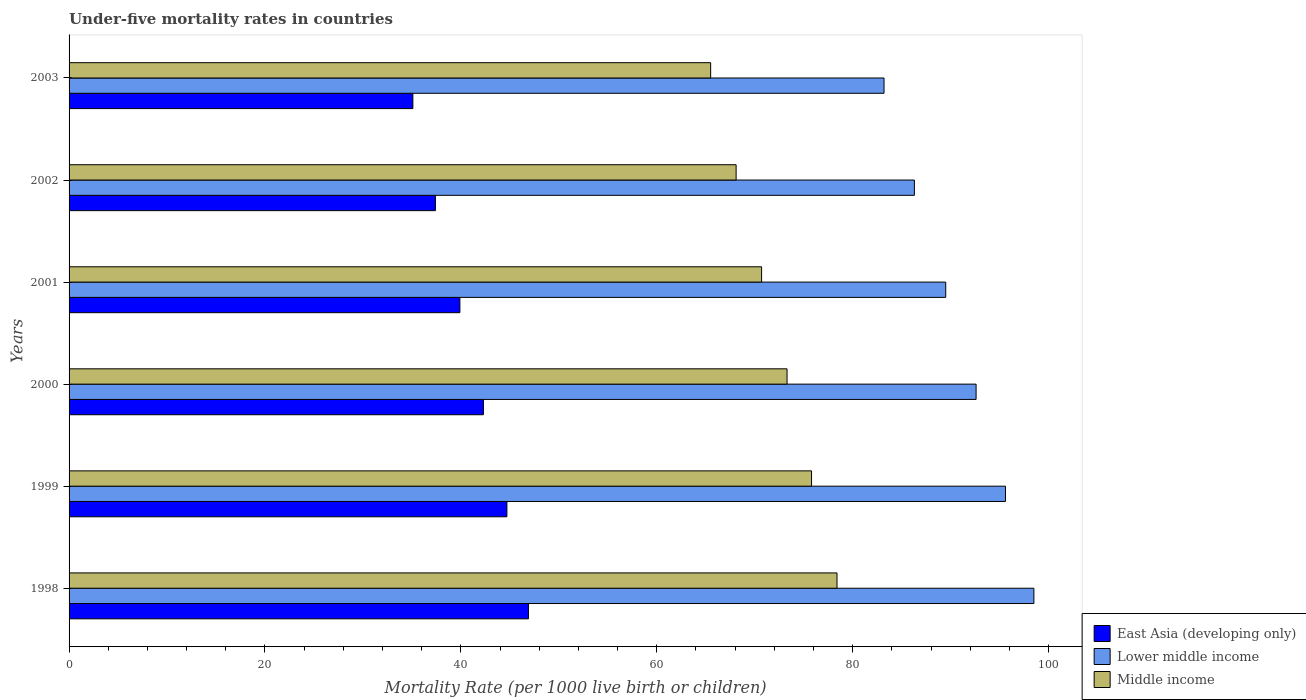How many bars are there on the 2nd tick from the top?
Your response must be concise. 3. How many bars are there on the 6th tick from the bottom?
Offer a very short reply. 3. What is the label of the 4th group of bars from the top?
Offer a very short reply. 2000. In how many cases, is the number of bars for a given year not equal to the number of legend labels?
Give a very brief answer. 0. What is the under-five mortality rate in Middle income in 2000?
Keep it short and to the point. 73.3. Across all years, what is the maximum under-five mortality rate in Lower middle income?
Your answer should be compact. 98.5. Across all years, what is the minimum under-five mortality rate in Middle income?
Provide a succinct answer. 65.5. In which year was the under-five mortality rate in East Asia (developing only) maximum?
Your answer should be compact. 1998. What is the total under-five mortality rate in Middle income in the graph?
Give a very brief answer. 431.8. What is the difference between the under-five mortality rate in Middle income in 1999 and that in 2003?
Offer a very short reply. 10.3. What is the difference between the under-five mortality rate in East Asia (developing only) in 2001 and the under-five mortality rate in Lower middle income in 1999?
Your answer should be compact. -55.7. What is the average under-five mortality rate in Middle income per year?
Give a very brief answer. 71.97. In the year 2002, what is the difference between the under-five mortality rate in Lower middle income and under-five mortality rate in Middle income?
Your answer should be compact. 18.2. In how many years, is the under-five mortality rate in East Asia (developing only) greater than 12 ?
Your response must be concise. 6. What is the ratio of the under-five mortality rate in East Asia (developing only) in 1999 to that in 2001?
Your answer should be very brief. 1.12. Is the difference between the under-five mortality rate in Lower middle income in 2001 and 2003 greater than the difference between the under-five mortality rate in Middle income in 2001 and 2003?
Offer a terse response. Yes. What is the difference between the highest and the second highest under-five mortality rate in Lower middle income?
Your response must be concise. 2.9. What is the difference between the highest and the lowest under-five mortality rate in Middle income?
Your answer should be very brief. 12.9. What does the 3rd bar from the top in 2002 represents?
Offer a terse response. East Asia (developing only). What does the 1st bar from the bottom in 1999 represents?
Offer a terse response. East Asia (developing only). What is the difference between two consecutive major ticks on the X-axis?
Your answer should be very brief. 20. Does the graph contain grids?
Provide a succinct answer. No. Where does the legend appear in the graph?
Keep it short and to the point. Bottom right. What is the title of the graph?
Your answer should be very brief. Under-five mortality rates in countries. What is the label or title of the X-axis?
Your response must be concise. Mortality Rate (per 1000 live birth or children). What is the label or title of the Y-axis?
Ensure brevity in your answer.  Years. What is the Mortality Rate (per 1000 live birth or children) in East Asia (developing only) in 1998?
Offer a very short reply. 46.9. What is the Mortality Rate (per 1000 live birth or children) of Lower middle income in 1998?
Your response must be concise. 98.5. What is the Mortality Rate (per 1000 live birth or children) in Middle income in 1998?
Provide a short and direct response. 78.4. What is the Mortality Rate (per 1000 live birth or children) in East Asia (developing only) in 1999?
Your response must be concise. 44.7. What is the Mortality Rate (per 1000 live birth or children) of Lower middle income in 1999?
Offer a very short reply. 95.6. What is the Mortality Rate (per 1000 live birth or children) of Middle income in 1999?
Your response must be concise. 75.8. What is the Mortality Rate (per 1000 live birth or children) of East Asia (developing only) in 2000?
Offer a very short reply. 42.3. What is the Mortality Rate (per 1000 live birth or children) in Lower middle income in 2000?
Your answer should be compact. 92.6. What is the Mortality Rate (per 1000 live birth or children) in Middle income in 2000?
Provide a short and direct response. 73.3. What is the Mortality Rate (per 1000 live birth or children) in East Asia (developing only) in 2001?
Provide a succinct answer. 39.9. What is the Mortality Rate (per 1000 live birth or children) of Lower middle income in 2001?
Provide a short and direct response. 89.5. What is the Mortality Rate (per 1000 live birth or children) of Middle income in 2001?
Your answer should be very brief. 70.7. What is the Mortality Rate (per 1000 live birth or children) in East Asia (developing only) in 2002?
Ensure brevity in your answer.  37.4. What is the Mortality Rate (per 1000 live birth or children) in Lower middle income in 2002?
Provide a succinct answer. 86.3. What is the Mortality Rate (per 1000 live birth or children) in Middle income in 2002?
Your response must be concise. 68.1. What is the Mortality Rate (per 1000 live birth or children) of East Asia (developing only) in 2003?
Provide a short and direct response. 35.1. What is the Mortality Rate (per 1000 live birth or children) of Lower middle income in 2003?
Your response must be concise. 83.2. What is the Mortality Rate (per 1000 live birth or children) in Middle income in 2003?
Your answer should be compact. 65.5. Across all years, what is the maximum Mortality Rate (per 1000 live birth or children) in East Asia (developing only)?
Provide a succinct answer. 46.9. Across all years, what is the maximum Mortality Rate (per 1000 live birth or children) in Lower middle income?
Ensure brevity in your answer.  98.5. Across all years, what is the maximum Mortality Rate (per 1000 live birth or children) in Middle income?
Ensure brevity in your answer.  78.4. Across all years, what is the minimum Mortality Rate (per 1000 live birth or children) in East Asia (developing only)?
Make the answer very short. 35.1. Across all years, what is the minimum Mortality Rate (per 1000 live birth or children) of Lower middle income?
Keep it short and to the point. 83.2. Across all years, what is the minimum Mortality Rate (per 1000 live birth or children) of Middle income?
Make the answer very short. 65.5. What is the total Mortality Rate (per 1000 live birth or children) of East Asia (developing only) in the graph?
Provide a short and direct response. 246.3. What is the total Mortality Rate (per 1000 live birth or children) of Lower middle income in the graph?
Give a very brief answer. 545.7. What is the total Mortality Rate (per 1000 live birth or children) in Middle income in the graph?
Your response must be concise. 431.8. What is the difference between the Mortality Rate (per 1000 live birth or children) in East Asia (developing only) in 1998 and that in 1999?
Make the answer very short. 2.2. What is the difference between the Mortality Rate (per 1000 live birth or children) of Lower middle income in 1998 and that in 1999?
Ensure brevity in your answer.  2.9. What is the difference between the Mortality Rate (per 1000 live birth or children) in Middle income in 1998 and that in 1999?
Offer a very short reply. 2.6. What is the difference between the Mortality Rate (per 1000 live birth or children) of Middle income in 1998 and that in 2000?
Your answer should be very brief. 5.1. What is the difference between the Mortality Rate (per 1000 live birth or children) in East Asia (developing only) in 1998 and that in 2001?
Ensure brevity in your answer.  7. What is the difference between the Mortality Rate (per 1000 live birth or children) of Lower middle income in 1998 and that in 2001?
Give a very brief answer. 9. What is the difference between the Mortality Rate (per 1000 live birth or children) of East Asia (developing only) in 1998 and that in 2002?
Give a very brief answer. 9.5. What is the difference between the Mortality Rate (per 1000 live birth or children) in Middle income in 1998 and that in 2002?
Your answer should be very brief. 10.3. What is the difference between the Mortality Rate (per 1000 live birth or children) in Lower middle income in 1998 and that in 2003?
Provide a short and direct response. 15.3. What is the difference between the Mortality Rate (per 1000 live birth or children) in East Asia (developing only) in 1999 and that in 2000?
Offer a very short reply. 2.4. What is the difference between the Mortality Rate (per 1000 live birth or children) in Middle income in 1999 and that in 2000?
Your response must be concise. 2.5. What is the difference between the Mortality Rate (per 1000 live birth or children) of East Asia (developing only) in 1999 and that in 2001?
Make the answer very short. 4.8. What is the difference between the Mortality Rate (per 1000 live birth or children) of Middle income in 1999 and that in 2001?
Provide a short and direct response. 5.1. What is the difference between the Mortality Rate (per 1000 live birth or children) of East Asia (developing only) in 1999 and that in 2002?
Provide a short and direct response. 7.3. What is the difference between the Mortality Rate (per 1000 live birth or children) in Lower middle income in 1999 and that in 2002?
Make the answer very short. 9.3. What is the difference between the Mortality Rate (per 1000 live birth or children) in East Asia (developing only) in 1999 and that in 2003?
Give a very brief answer. 9.6. What is the difference between the Mortality Rate (per 1000 live birth or children) of Lower middle income in 1999 and that in 2003?
Ensure brevity in your answer.  12.4. What is the difference between the Mortality Rate (per 1000 live birth or children) of East Asia (developing only) in 2000 and that in 2001?
Give a very brief answer. 2.4. What is the difference between the Mortality Rate (per 1000 live birth or children) of Middle income in 2000 and that in 2001?
Provide a short and direct response. 2.6. What is the difference between the Mortality Rate (per 1000 live birth or children) of Lower middle income in 2000 and that in 2002?
Offer a terse response. 6.3. What is the difference between the Mortality Rate (per 1000 live birth or children) in Middle income in 2000 and that in 2002?
Offer a very short reply. 5.2. What is the difference between the Mortality Rate (per 1000 live birth or children) of Middle income in 2000 and that in 2003?
Your answer should be very brief. 7.8. What is the difference between the Mortality Rate (per 1000 live birth or children) of East Asia (developing only) in 2001 and that in 2002?
Provide a succinct answer. 2.5. What is the difference between the Mortality Rate (per 1000 live birth or children) in Lower middle income in 2001 and that in 2002?
Ensure brevity in your answer.  3.2. What is the difference between the Mortality Rate (per 1000 live birth or children) of Middle income in 2001 and that in 2002?
Offer a terse response. 2.6. What is the difference between the Mortality Rate (per 1000 live birth or children) of Lower middle income in 2002 and that in 2003?
Provide a succinct answer. 3.1. What is the difference between the Mortality Rate (per 1000 live birth or children) in East Asia (developing only) in 1998 and the Mortality Rate (per 1000 live birth or children) in Lower middle income in 1999?
Provide a short and direct response. -48.7. What is the difference between the Mortality Rate (per 1000 live birth or children) in East Asia (developing only) in 1998 and the Mortality Rate (per 1000 live birth or children) in Middle income in 1999?
Give a very brief answer. -28.9. What is the difference between the Mortality Rate (per 1000 live birth or children) in Lower middle income in 1998 and the Mortality Rate (per 1000 live birth or children) in Middle income in 1999?
Offer a very short reply. 22.7. What is the difference between the Mortality Rate (per 1000 live birth or children) of East Asia (developing only) in 1998 and the Mortality Rate (per 1000 live birth or children) of Lower middle income in 2000?
Give a very brief answer. -45.7. What is the difference between the Mortality Rate (per 1000 live birth or children) of East Asia (developing only) in 1998 and the Mortality Rate (per 1000 live birth or children) of Middle income in 2000?
Keep it short and to the point. -26.4. What is the difference between the Mortality Rate (per 1000 live birth or children) of Lower middle income in 1998 and the Mortality Rate (per 1000 live birth or children) of Middle income in 2000?
Keep it short and to the point. 25.2. What is the difference between the Mortality Rate (per 1000 live birth or children) in East Asia (developing only) in 1998 and the Mortality Rate (per 1000 live birth or children) in Lower middle income in 2001?
Keep it short and to the point. -42.6. What is the difference between the Mortality Rate (per 1000 live birth or children) of East Asia (developing only) in 1998 and the Mortality Rate (per 1000 live birth or children) of Middle income in 2001?
Your response must be concise. -23.8. What is the difference between the Mortality Rate (per 1000 live birth or children) in Lower middle income in 1998 and the Mortality Rate (per 1000 live birth or children) in Middle income in 2001?
Provide a succinct answer. 27.8. What is the difference between the Mortality Rate (per 1000 live birth or children) of East Asia (developing only) in 1998 and the Mortality Rate (per 1000 live birth or children) of Lower middle income in 2002?
Offer a very short reply. -39.4. What is the difference between the Mortality Rate (per 1000 live birth or children) of East Asia (developing only) in 1998 and the Mortality Rate (per 1000 live birth or children) of Middle income in 2002?
Offer a terse response. -21.2. What is the difference between the Mortality Rate (per 1000 live birth or children) of Lower middle income in 1998 and the Mortality Rate (per 1000 live birth or children) of Middle income in 2002?
Ensure brevity in your answer.  30.4. What is the difference between the Mortality Rate (per 1000 live birth or children) of East Asia (developing only) in 1998 and the Mortality Rate (per 1000 live birth or children) of Lower middle income in 2003?
Make the answer very short. -36.3. What is the difference between the Mortality Rate (per 1000 live birth or children) of East Asia (developing only) in 1998 and the Mortality Rate (per 1000 live birth or children) of Middle income in 2003?
Offer a terse response. -18.6. What is the difference between the Mortality Rate (per 1000 live birth or children) of East Asia (developing only) in 1999 and the Mortality Rate (per 1000 live birth or children) of Lower middle income in 2000?
Make the answer very short. -47.9. What is the difference between the Mortality Rate (per 1000 live birth or children) in East Asia (developing only) in 1999 and the Mortality Rate (per 1000 live birth or children) in Middle income in 2000?
Your answer should be compact. -28.6. What is the difference between the Mortality Rate (per 1000 live birth or children) in Lower middle income in 1999 and the Mortality Rate (per 1000 live birth or children) in Middle income in 2000?
Offer a terse response. 22.3. What is the difference between the Mortality Rate (per 1000 live birth or children) of East Asia (developing only) in 1999 and the Mortality Rate (per 1000 live birth or children) of Lower middle income in 2001?
Provide a short and direct response. -44.8. What is the difference between the Mortality Rate (per 1000 live birth or children) of Lower middle income in 1999 and the Mortality Rate (per 1000 live birth or children) of Middle income in 2001?
Give a very brief answer. 24.9. What is the difference between the Mortality Rate (per 1000 live birth or children) in East Asia (developing only) in 1999 and the Mortality Rate (per 1000 live birth or children) in Lower middle income in 2002?
Provide a short and direct response. -41.6. What is the difference between the Mortality Rate (per 1000 live birth or children) of East Asia (developing only) in 1999 and the Mortality Rate (per 1000 live birth or children) of Middle income in 2002?
Your answer should be very brief. -23.4. What is the difference between the Mortality Rate (per 1000 live birth or children) in Lower middle income in 1999 and the Mortality Rate (per 1000 live birth or children) in Middle income in 2002?
Your answer should be very brief. 27.5. What is the difference between the Mortality Rate (per 1000 live birth or children) of East Asia (developing only) in 1999 and the Mortality Rate (per 1000 live birth or children) of Lower middle income in 2003?
Provide a succinct answer. -38.5. What is the difference between the Mortality Rate (per 1000 live birth or children) in East Asia (developing only) in 1999 and the Mortality Rate (per 1000 live birth or children) in Middle income in 2003?
Ensure brevity in your answer.  -20.8. What is the difference between the Mortality Rate (per 1000 live birth or children) in Lower middle income in 1999 and the Mortality Rate (per 1000 live birth or children) in Middle income in 2003?
Give a very brief answer. 30.1. What is the difference between the Mortality Rate (per 1000 live birth or children) of East Asia (developing only) in 2000 and the Mortality Rate (per 1000 live birth or children) of Lower middle income in 2001?
Offer a very short reply. -47.2. What is the difference between the Mortality Rate (per 1000 live birth or children) of East Asia (developing only) in 2000 and the Mortality Rate (per 1000 live birth or children) of Middle income in 2001?
Offer a terse response. -28.4. What is the difference between the Mortality Rate (per 1000 live birth or children) of Lower middle income in 2000 and the Mortality Rate (per 1000 live birth or children) of Middle income in 2001?
Your response must be concise. 21.9. What is the difference between the Mortality Rate (per 1000 live birth or children) of East Asia (developing only) in 2000 and the Mortality Rate (per 1000 live birth or children) of Lower middle income in 2002?
Keep it short and to the point. -44. What is the difference between the Mortality Rate (per 1000 live birth or children) of East Asia (developing only) in 2000 and the Mortality Rate (per 1000 live birth or children) of Middle income in 2002?
Keep it short and to the point. -25.8. What is the difference between the Mortality Rate (per 1000 live birth or children) of East Asia (developing only) in 2000 and the Mortality Rate (per 1000 live birth or children) of Lower middle income in 2003?
Make the answer very short. -40.9. What is the difference between the Mortality Rate (per 1000 live birth or children) of East Asia (developing only) in 2000 and the Mortality Rate (per 1000 live birth or children) of Middle income in 2003?
Your answer should be compact. -23.2. What is the difference between the Mortality Rate (per 1000 live birth or children) of Lower middle income in 2000 and the Mortality Rate (per 1000 live birth or children) of Middle income in 2003?
Your answer should be compact. 27.1. What is the difference between the Mortality Rate (per 1000 live birth or children) in East Asia (developing only) in 2001 and the Mortality Rate (per 1000 live birth or children) in Lower middle income in 2002?
Offer a very short reply. -46.4. What is the difference between the Mortality Rate (per 1000 live birth or children) in East Asia (developing only) in 2001 and the Mortality Rate (per 1000 live birth or children) in Middle income in 2002?
Give a very brief answer. -28.2. What is the difference between the Mortality Rate (per 1000 live birth or children) of Lower middle income in 2001 and the Mortality Rate (per 1000 live birth or children) of Middle income in 2002?
Your answer should be very brief. 21.4. What is the difference between the Mortality Rate (per 1000 live birth or children) of East Asia (developing only) in 2001 and the Mortality Rate (per 1000 live birth or children) of Lower middle income in 2003?
Offer a terse response. -43.3. What is the difference between the Mortality Rate (per 1000 live birth or children) of East Asia (developing only) in 2001 and the Mortality Rate (per 1000 live birth or children) of Middle income in 2003?
Provide a succinct answer. -25.6. What is the difference between the Mortality Rate (per 1000 live birth or children) of East Asia (developing only) in 2002 and the Mortality Rate (per 1000 live birth or children) of Lower middle income in 2003?
Offer a terse response. -45.8. What is the difference between the Mortality Rate (per 1000 live birth or children) of East Asia (developing only) in 2002 and the Mortality Rate (per 1000 live birth or children) of Middle income in 2003?
Provide a succinct answer. -28.1. What is the difference between the Mortality Rate (per 1000 live birth or children) of Lower middle income in 2002 and the Mortality Rate (per 1000 live birth or children) of Middle income in 2003?
Keep it short and to the point. 20.8. What is the average Mortality Rate (per 1000 live birth or children) in East Asia (developing only) per year?
Your response must be concise. 41.05. What is the average Mortality Rate (per 1000 live birth or children) in Lower middle income per year?
Provide a succinct answer. 90.95. What is the average Mortality Rate (per 1000 live birth or children) in Middle income per year?
Make the answer very short. 71.97. In the year 1998, what is the difference between the Mortality Rate (per 1000 live birth or children) in East Asia (developing only) and Mortality Rate (per 1000 live birth or children) in Lower middle income?
Your response must be concise. -51.6. In the year 1998, what is the difference between the Mortality Rate (per 1000 live birth or children) of East Asia (developing only) and Mortality Rate (per 1000 live birth or children) of Middle income?
Provide a short and direct response. -31.5. In the year 1998, what is the difference between the Mortality Rate (per 1000 live birth or children) of Lower middle income and Mortality Rate (per 1000 live birth or children) of Middle income?
Provide a succinct answer. 20.1. In the year 1999, what is the difference between the Mortality Rate (per 1000 live birth or children) in East Asia (developing only) and Mortality Rate (per 1000 live birth or children) in Lower middle income?
Your answer should be very brief. -50.9. In the year 1999, what is the difference between the Mortality Rate (per 1000 live birth or children) in East Asia (developing only) and Mortality Rate (per 1000 live birth or children) in Middle income?
Provide a succinct answer. -31.1. In the year 1999, what is the difference between the Mortality Rate (per 1000 live birth or children) in Lower middle income and Mortality Rate (per 1000 live birth or children) in Middle income?
Ensure brevity in your answer.  19.8. In the year 2000, what is the difference between the Mortality Rate (per 1000 live birth or children) in East Asia (developing only) and Mortality Rate (per 1000 live birth or children) in Lower middle income?
Offer a terse response. -50.3. In the year 2000, what is the difference between the Mortality Rate (per 1000 live birth or children) of East Asia (developing only) and Mortality Rate (per 1000 live birth or children) of Middle income?
Provide a short and direct response. -31. In the year 2000, what is the difference between the Mortality Rate (per 1000 live birth or children) in Lower middle income and Mortality Rate (per 1000 live birth or children) in Middle income?
Offer a terse response. 19.3. In the year 2001, what is the difference between the Mortality Rate (per 1000 live birth or children) in East Asia (developing only) and Mortality Rate (per 1000 live birth or children) in Lower middle income?
Provide a short and direct response. -49.6. In the year 2001, what is the difference between the Mortality Rate (per 1000 live birth or children) in East Asia (developing only) and Mortality Rate (per 1000 live birth or children) in Middle income?
Offer a very short reply. -30.8. In the year 2001, what is the difference between the Mortality Rate (per 1000 live birth or children) of Lower middle income and Mortality Rate (per 1000 live birth or children) of Middle income?
Ensure brevity in your answer.  18.8. In the year 2002, what is the difference between the Mortality Rate (per 1000 live birth or children) of East Asia (developing only) and Mortality Rate (per 1000 live birth or children) of Lower middle income?
Make the answer very short. -48.9. In the year 2002, what is the difference between the Mortality Rate (per 1000 live birth or children) in East Asia (developing only) and Mortality Rate (per 1000 live birth or children) in Middle income?
Give a very brief answer. -30.7. In the year 2003, what is the difference between the Mortality Rate (per 1000 live birth or children) in East Asia (developing only) and Mortality Rate (per 1000 live birth or children) in Lower middle income?
Provide a succinct answer. -48.1. In the year 2003, what is the difference between the Mortality Rate (per 1000 live birth or children) in East Asia (developing only) and Mortality Rate (per 1000 live birth or children) in Middle income?
Give a very brief answer. -30.4. What is the ratio of the Mortality Rate (per 1000 live birth or children) in East Asia (developing only) in 1998 to that in 1999?
Make the answer very short. 1.05. What is the ratio of the Mortality Rate (per 1000 live birth or children) in Lower middle income in 1998 to that in 1999?
Offer a very short reply. 1.03. What is the ratio of the Mortality Rate (per 1000 live birth or children) of Middle income in 1998 to that in 1999?
Your answer should be compact. 1.03. What is the ratio of the Mortality Rate (per 1000 live birth or children) in East Asia (developing only) in 1998 to that in 2000?
Keep it short and to the point. 1.11. What is the ratio of the Mortality Rate (per 1000 live birth or children) in Lower middle income in 1998 to that in 2000?
Provide a short and direct response. 1.06. What is the ratio of the Mortality Rate (per 1000 live birth or children) of Middle income in 1998 to that in 2000?
Your answer should be very brief. 1.07. What is the ratio of the Mortality Rate (per 1000 live birth or children) of East Asia (developing only) in 1998 to that in 2001?
Provide a short and direct response. 1.18. What is the ratio of the Mortality Rate (per 1000 live birth or children) in Lower middle income in 1998 to that in 2001?
Make the answer very short. 1.1. What is the ratio of the Mortality Rate (per 1000 live birth or children) in Middle income in 1998 to that in 2001?
Make the answer very short. 1.11. What is the ratio of the Mortality Rate (per 1000 live birth or children) of East Asia (developing only) in 1998 to that in 2002?
Provide a succinct answer. 1.25. What is the ratio of the Mortality Rate (per 1000 live birth or children) of Lower middle income in 1998 to that in 2002?
Provide a succinct answer. 1.14. What is the ratio of the Mortality Rate (per 1000 live birth or children) in Middle income in 1998 to that in 2002?
Your answer should be very brief. 1.15. What is the ratio of the Mortality Rate (per 1000 live birth or children) of East Asia (developing only) in 1998 to that in 2003?
Your answer should be compact. 1.34. What is the ratio of the Mortality Rate (per 1000 live birth or children) in Lower middle income in 1998 to that in 2003?
Offer a very short reply. 1.18. What is the ratio of the Mortality Rate (per 1000 live birth or children) in Middle income in 1998 to that in 2003?
Offer a very short reply. 1.2. What is the ratio of the Mortality Rate (per 1000 live birth or children) in East Asia (developing only) in 1999 to that in 2000?
Provide a succinct answer. 1.06. What is the ratio of the Mortality Rate (per 1000 live birth or children) in Lower middle income in 1999 to that in 2000?
Your response must be concise. 1.03. What is the ratio of the Mortality Rate (per 1000 live birth or children) in Middle income in 1999 to that in 2000?
Your response must be concise. 1.03. What is the ratio of the Mortality Rate (per 1000 live birth or children) in East Asia (developing only) in 1999 to that in 2001?
Provide a succinct answer. 1.12. What is the ratio of the Mortality Rate (per 1000 live birth or children) in Lower middle income in 1999 to that in 2001?
Offer a terse response. 1.07. What is the ratio of the Mortality Rate (per 1000 live birth or children) in Middle income in 1999 to that in 2001?
Give a very brief answer. 1.07. What is the ratio of the Mortality Rate (per 1000 live birth or children) in East Asia (developing only) in 1999 to that in 2002?
Your response must be concise. 1.2. What is the ratio of the Mortality Rate (per 1000 live birth or children) of Lower middle income in 1999 to that in 2002?
Provide a short and direct response. 1.11. What is the ratio of the Mortality Rate (per 1000 live birth or children) in Middle income in 1999 to that in 2002?
Your answer should be very brief. 1.11. What is the ratio of the Mortality Rate (per 1000 live birth or children) of East Asia (developing only) in 1999 to that in 2003?
Offer a very short reply. 1.27. What is the ratio of the Mortality Rate (per 1000 live birth or children) of Lower middle income in 1999 to that in 2003?
Keep it short and to the point. 1.15. What is the ratio of the Mortality Rate (per 1000 live birth or children) of Middle income in 1999 to that in 2003?
Your answer should be compact. 1.16. What is the ratio of the Mortality Rate (per 1000 live birth or children) in East Asia (developing only) in 2000 to that in 2001?
Offer a terse response. 1.06. What is the ratio of the Mortality Rate (per 1000 live birth or children) of Lower middle income in 2000 to that in 2001?
Your response must be concise. 1.03. What is the ratio of the Mortality Rate (per 1000 live birth or children) of Middle income in 2000 to that in 2001?
Ensure brevity in your answer.  1.04. What is the ratio of the Mortality Rate (per 1000 live birth or children) in East Asia (developing only) in 2000 to that in 2002?
Your response must be concise. 1.13. What is the ratio of the Mortality Rate (per 1000 live birth or children) of Lower middle income in 2000 to that in 2002?
Your response must be concise. 1.07. What is the ratio of the Mortality Rate (per 1000 live birth or children) of Middle income in 2000 to that in 2002?
Ensure brevity in your answer.  1.08. What is the ratio of the Mortality Rate (per 1000 live birth or children) of East Asia (developing only) in 2000 to that in 2003?
Provide a short and direct response. 1.21. What is the ratio of the Mortality Rate (per 1000 live birth or children) of Lower middle income in 2000 to that in 2003?
Offer a terse response. 1.11. What is the ratio of the Mortality Rate (per 1000 live birth or children) of Middle income in 2000 to that in 2003?
Your response must be concise. 1.12. What is the ratio of the Mortality Rate (per 1000 live birth or children) in East Asia (developing only) in 2001 to that in 2002?
Give a very brief answer. 1.07. What is the ratio of the Mortality Rate (per 1000 live birth or children) of Lower middle income in 2001 to that in 2002?
Your response must be concise. 1.04. What is the ratio of the Mortality Rate (per 1000 live birth or children) of Middle income in 2001 to that in 2002?
Your response must be concise. 1.04. What is the ratio of the Mortality Rate (per 1000 live birth or children) of East Asia (developing only) in 2001 to that in 2003?
Provide a short and direct response. 1.14. What is the ratio of the Mortality Rate (per 1000 live birth or children) of Lower middle income in 2001 to that in 2003?
Make the answer very short. 1.08. What is the ratio of the Mortality Rate (per 1000 live birth or children) in Middle income in 2001 to that in 2003?
Offer a very short reply. 1.08. What is the ratio of the Mortality Rate (per 1000 live birth or children) in East Asia (developing only) in 2002 to that in 2003?
Your answer should be very brief. 1.07. What is the ratio of the Mortality Rate (per 1000 live birth or children) in Lower middle income in 2002 to that in 2003?
Give a very brief answer. 1.04. What is the ratio of the Mortality Rate (per 1000 live birth or children) of Middle income in 2002 to that in 2003?
Give a very brief answer. 1.04. What is the difference between the highest and the second highest Mortality Rate (per 1000 live birth or children) in Lower middle income?
Ensure brevity in your answer.  2.9. What is the difference between the highest and the lowest Mortality Rate (per 1000 live birth or children) of Lower middle income?
Your response must be concise. 15.3. What is the difference between the highest and the lowest Mortality Rate (per 1000 live birth or children) in Middle income?
Make the answer very short. 12.9. 